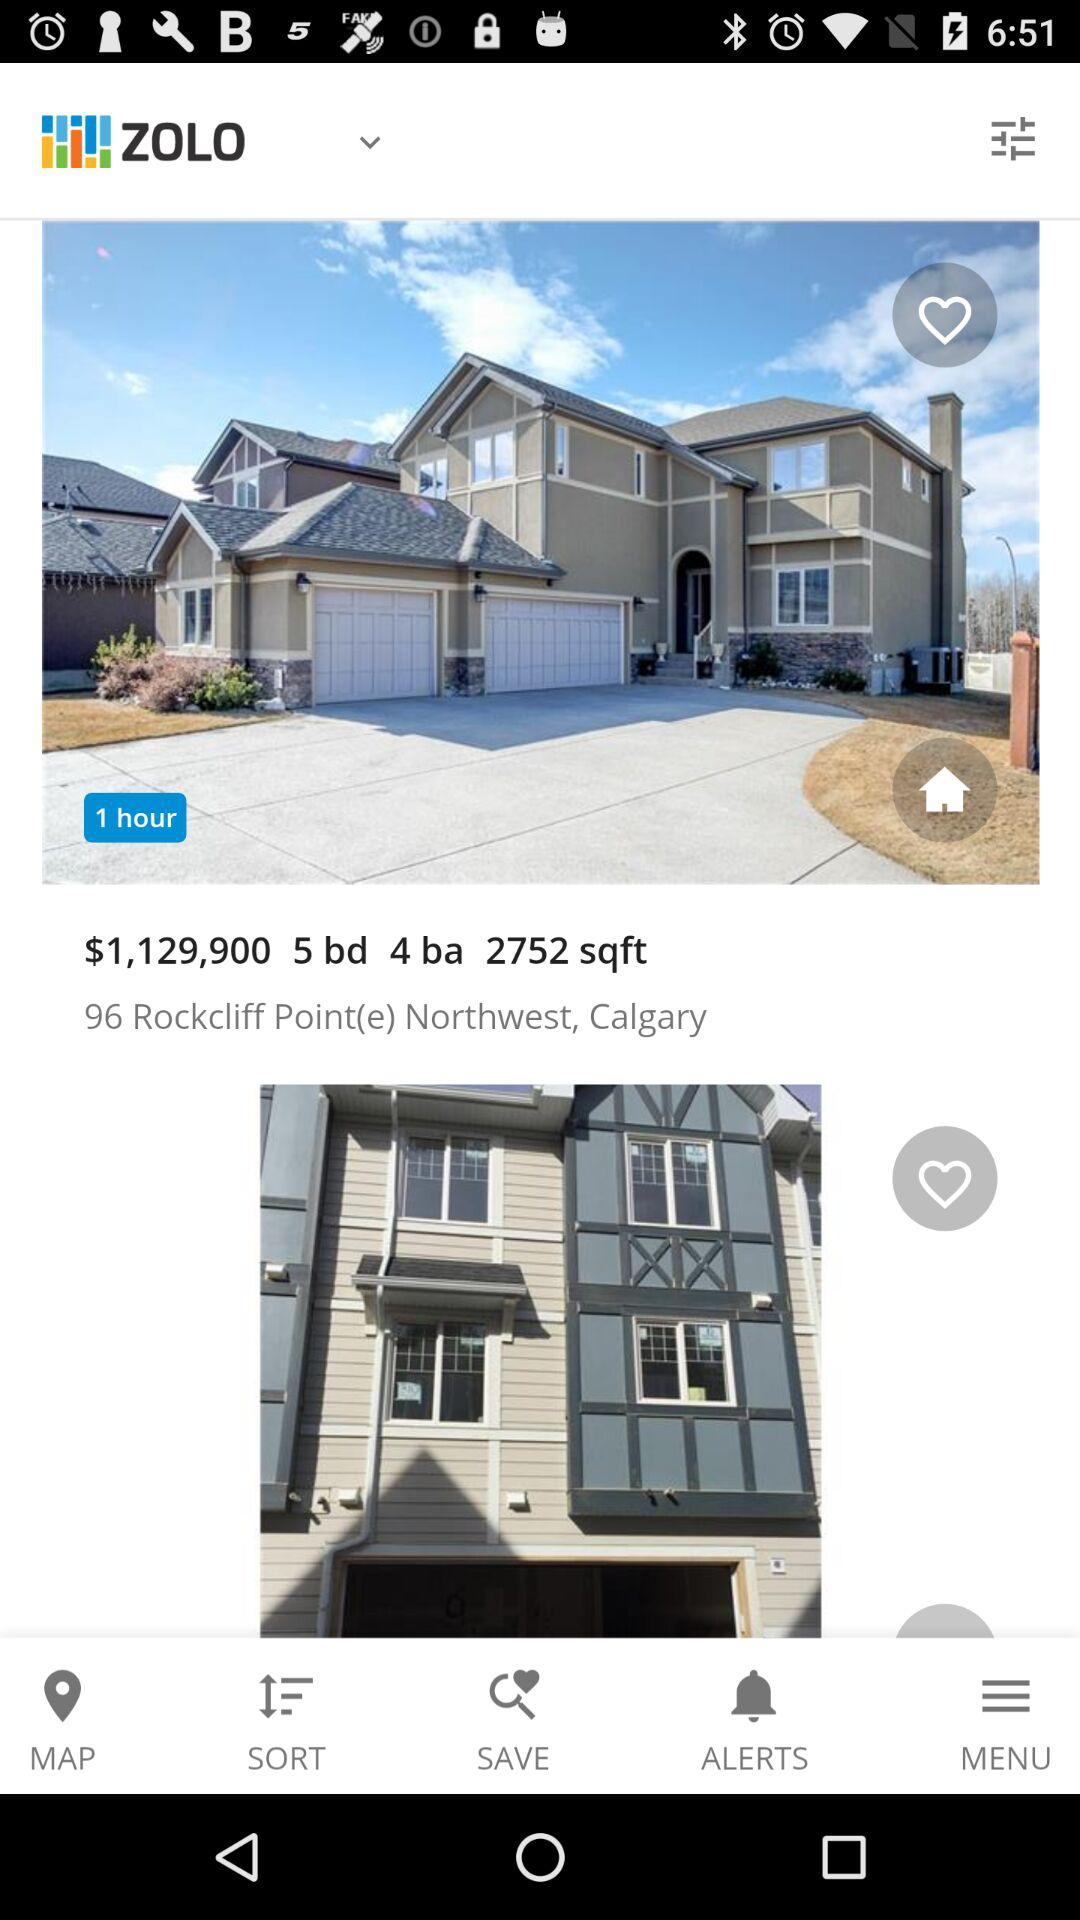What is the displayed price? The displayed price is $1,129,900. 